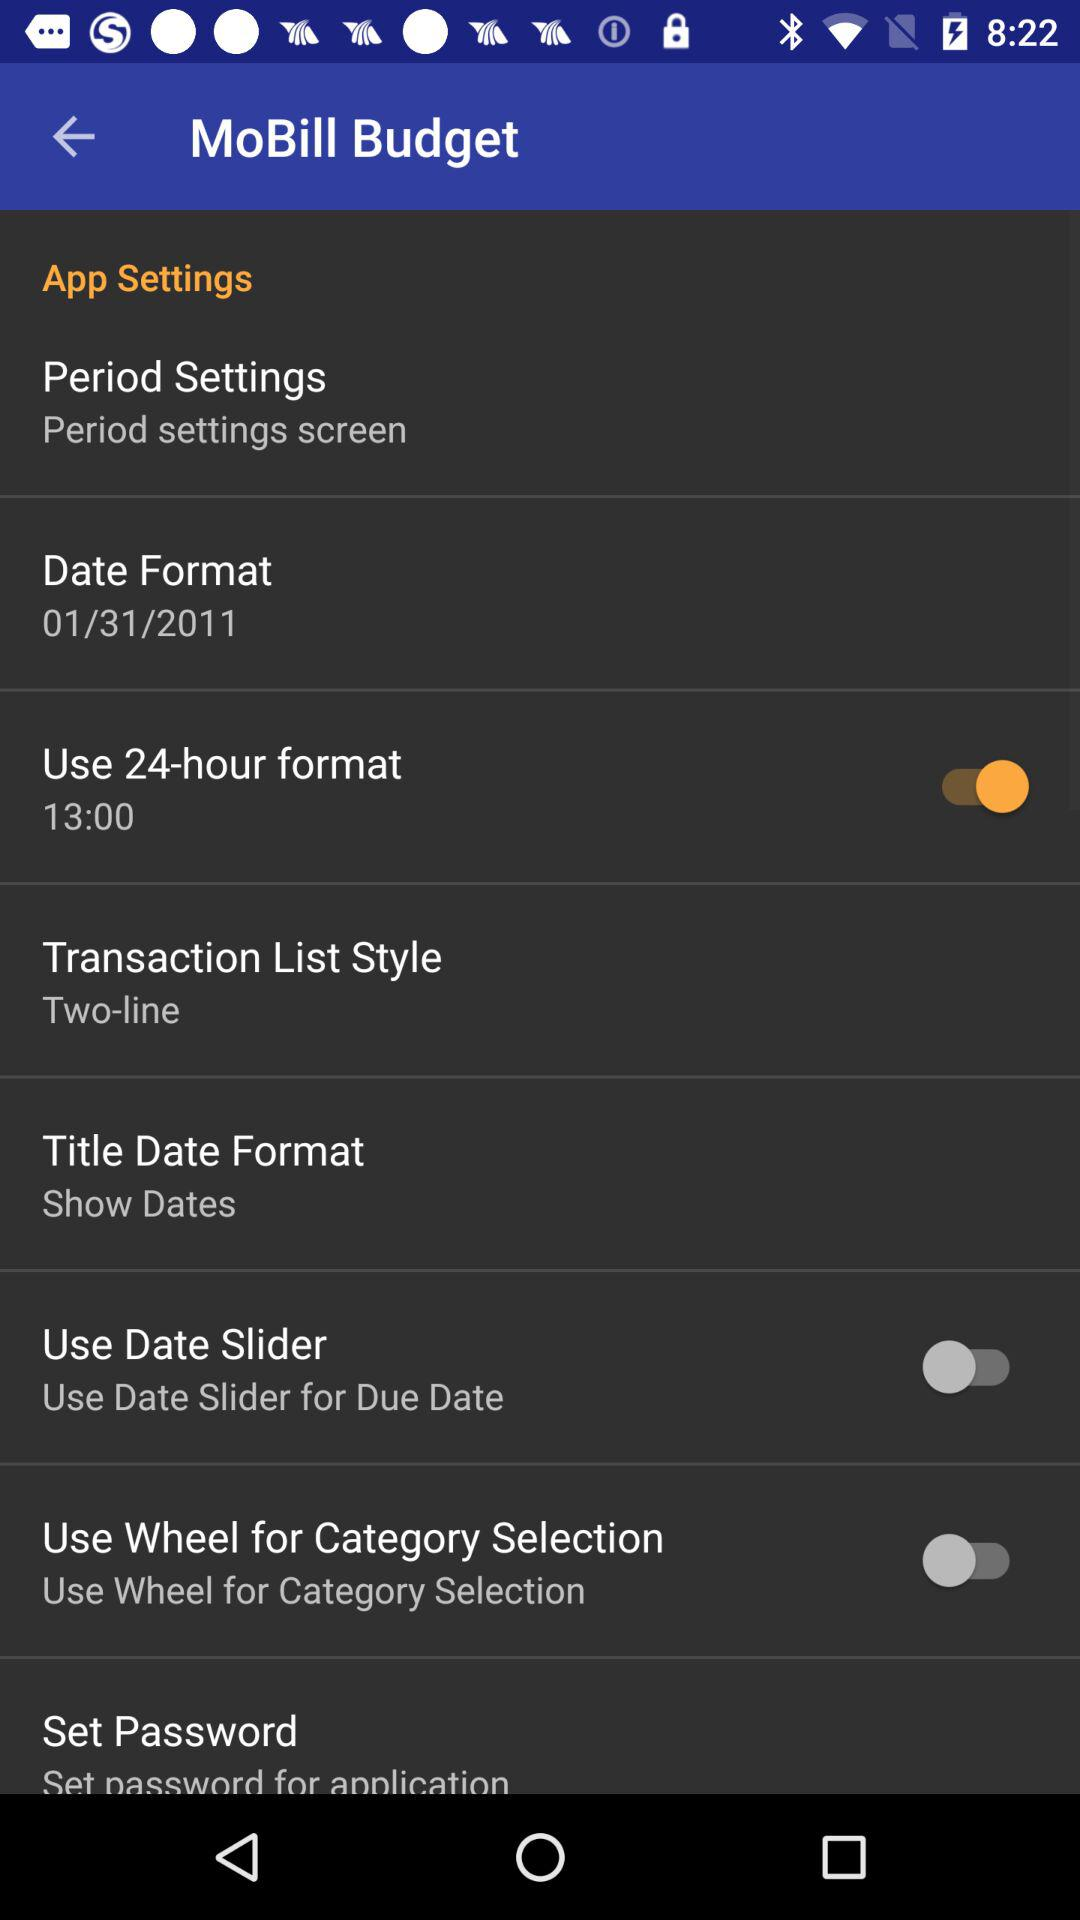Which option is enabled? The option that is enabled is "Use 24-hour format". 